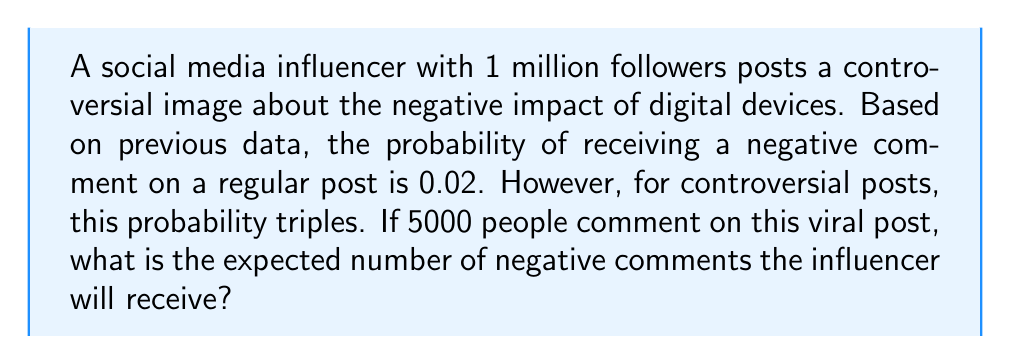Help me with this question. Let's approach this step-by-step:

1) First, we need to determine the probability of receiving a negative comment on this controversial post.
   - For a regular post, the probability is 0.02
   - For a controversial post, this probability triples
   - So, the new probability is: $3 \times 0.02 = 0.06$

2) Now, we need to calculate the expected number of negative comments.
   - In probability theory, the expected value of a binomial distribution is given by the formula:
     $$ E(X) = np $$
   Where:
     $n$ = number of trials (in this case, total number of comments)
     $p$ = probability of success on each trial (in this case, probability of a negative comment)

3) We can now plug in our values:
   $n = 5000$ (total number of comments)
   $p = 0.06$ (probability of a negative comment)

4) Calculating the expected value:
   $$ E(X) = 5000 \times 0.06 = 300 $$

Thus, the expected number of negative comments is 300.
Answer: 300 negative comments 